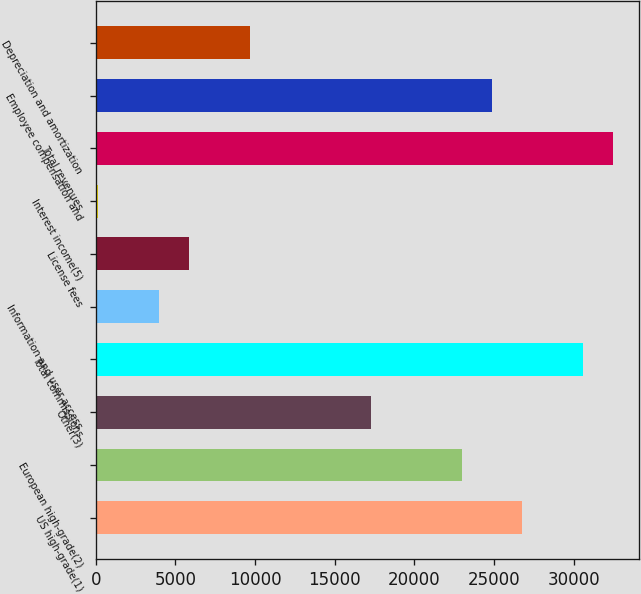<chart> <loc_0><loc_0><loc_500><loc_500><bar_chart><fcel>US high-grade(1)<fcel>European high-grade(2)<fcel>Other(3)<fcel>Total commissions<fcel>Information and user access<fcel>License fees<fcel>Interest income(5)<fcel>Total revenues<fcel>Employee compensation and<fcel>Depreciation and amortization<nl><fcel>26780.6<fcel>22976.8<fcel>17271.1<fcel>30584.4<fcel>3957.8<fcel>5859.7<fcel>154<fcel>32486.3<fcel>24878.7<fcel>9663.5<nl></chart> 